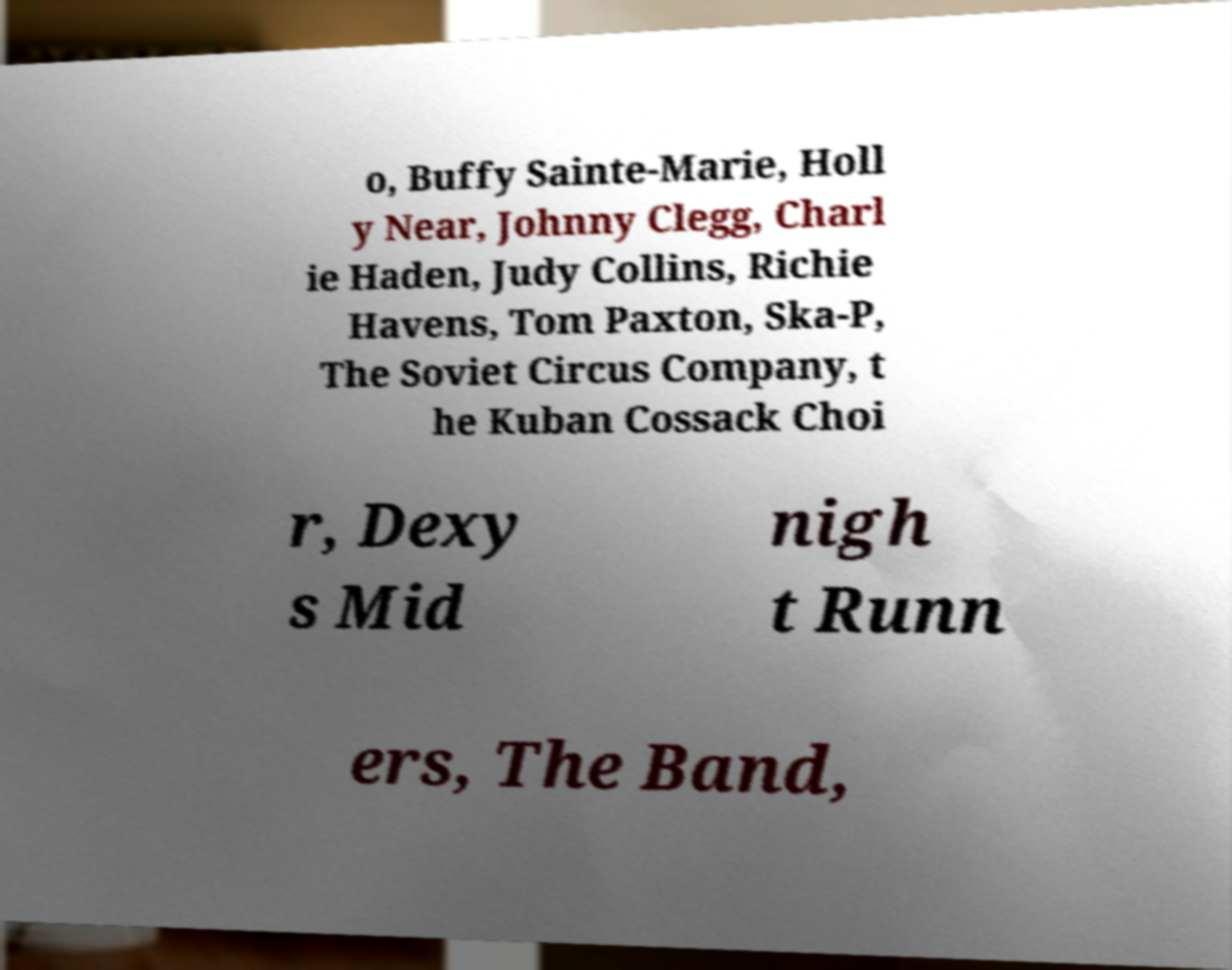Please identify and transcribe the text found in this image. o, Buffy Sainte-Marie, Holl y Near, Johnny Clegg, Charl ie Haden, Judy Collins, Richie Havens, Tom Paxton, Ska-P, The Soviet Circus Company, t he Kuban Cossack Choi r, Dexy s Mid nigh t Runn ers, The Band, 